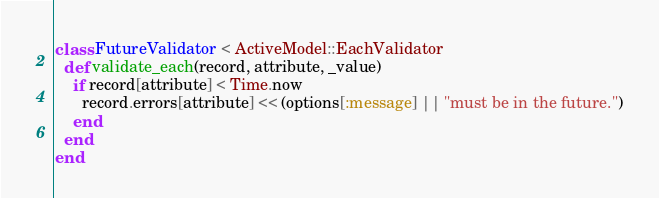<code> <loc_0><loc_0><loc_500><loc_500><_Ruby_>class FutureValidator < ActiveModel::EachValidator
  def validate_each(record, attribute, _value)
    if record[attribute] < Time.now
      record.errors[attribute] << (options[:message] || "must be in the future.")
    end
  end
end</code> 